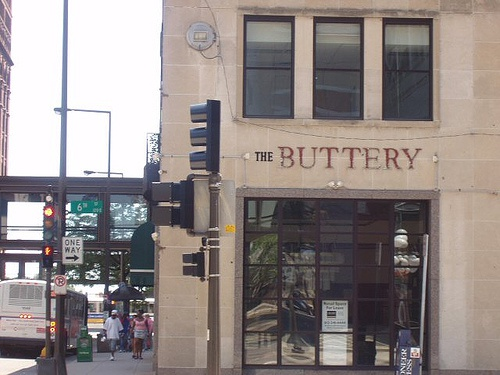Describe the objects in this image and their specific colors. I can see bus in gray, darkgray, and lightgray tones, traffic light in gray, black, and darkgray tones, traffic light in gray, black, and darkblue tones, bus in gray and black tones, and traffic light in gray, black, and purple tones in this image. 